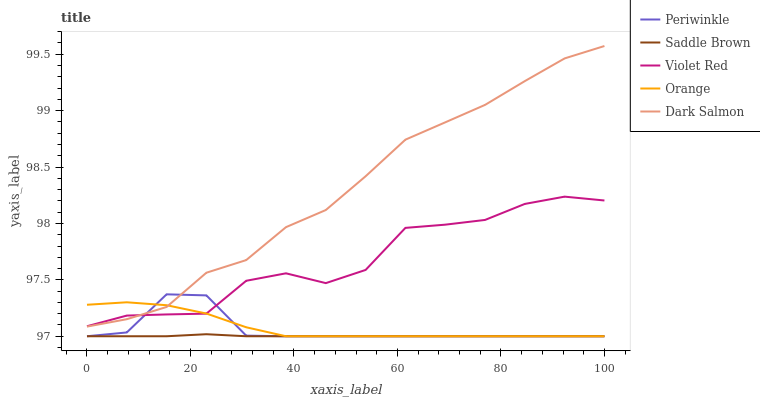Does Saddle Brown have the minimum area under the curve?
Answer yes or no. Yes. Does Dark Salmon have the maximum area under the curve?
Answer yes or no. Yes. Does Violet Red have the minimum area under the curve?
Answer yes or no. No. Does Violet Red have the maximum area under the curve?
Answer yes or no. No. Is Saddle Brown the smoothest?
Answer yes or no. Yes. Is Violet Red the roughest?
Answer yes or no. Yes. Is Periwinkle the smoothest?
Answer yes or no. No. Is Periwinkle the roughest?
Answer yes or no. No. Does Orange have the lowest value?
Answer yes or no. Yes. Does Violet Red have the lowest value?
Answer yes or no. No. Does Dark Salmon have the highest value?
Answer yes or no. Yes. Does Violet Red have the highest value?
Answer yes or no. No. Is Saddle Brown less than Violet Red?
Answer yes or no. Yes. Is Violet Red greater than Saddle Brown?
Answer yes or no. Yes. Does Orange intersect Periwinkle?
Answer yes or no. Yes. Is Orange less than Periwinkle?
Answer yes or no. No. Is Orange greater than Periwinkle?
Answer yes or no. No. Does Saddle Brown intersect Violet Red?
Answer yes or no. No. 